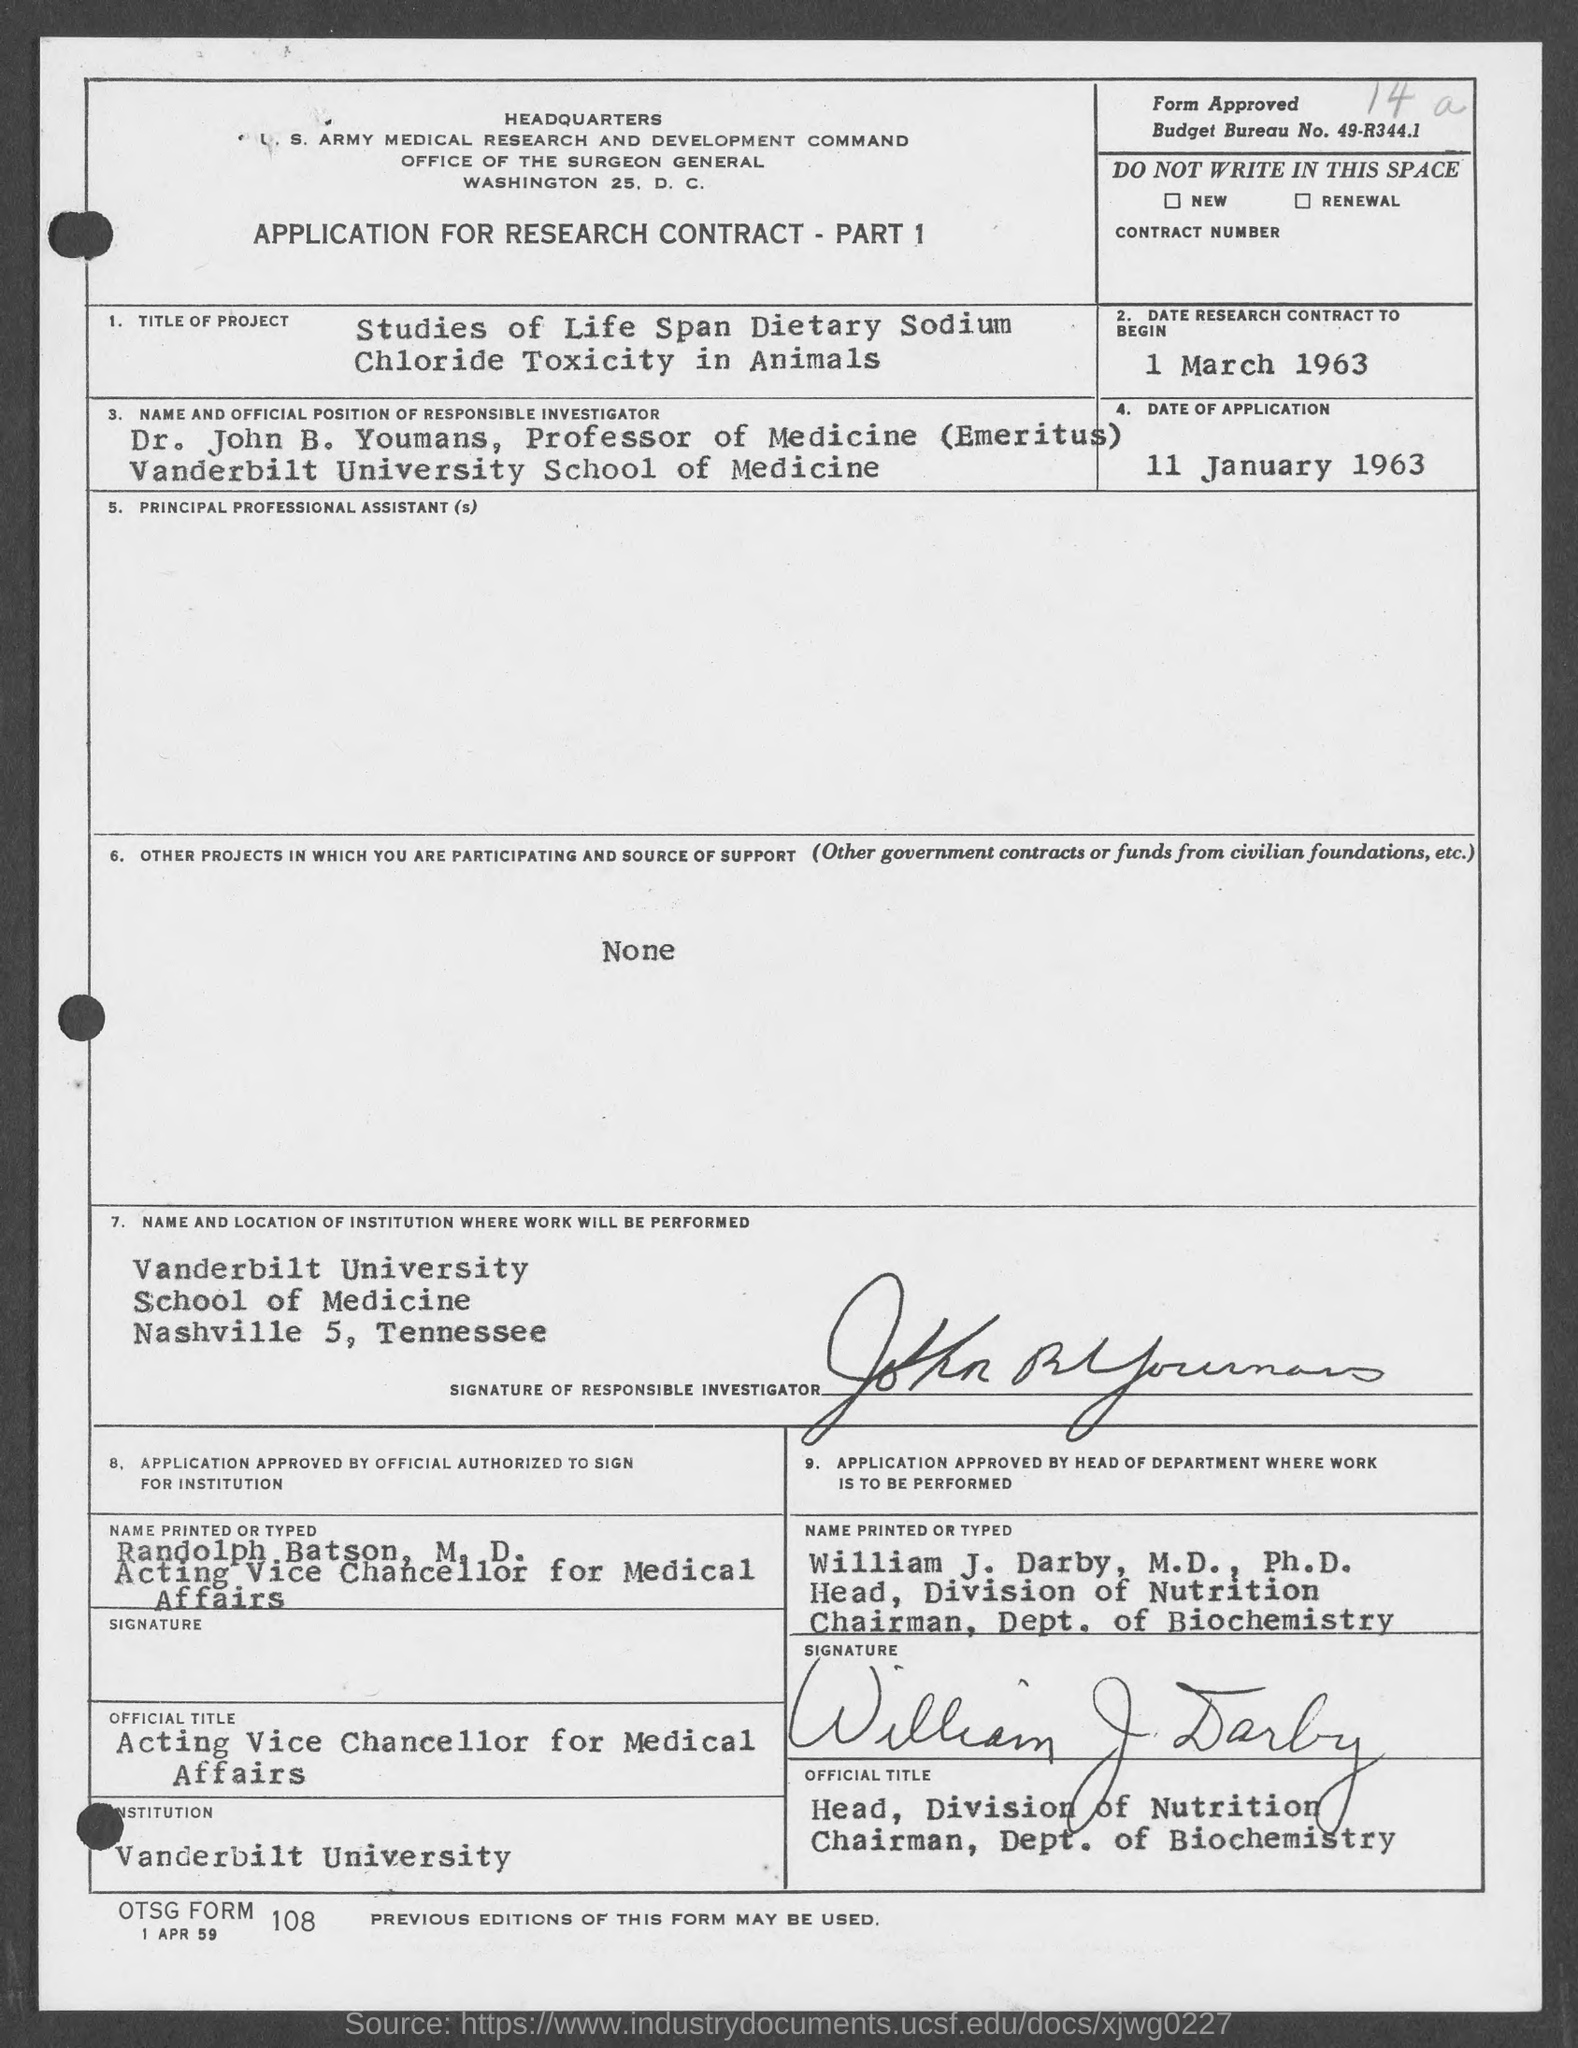What is the budget bureau no. mentioned in the given form ?
Your answer should be compact. 49-R344.1. What is the date of research contract to begin as mentioned in the give page ?
Your answer should be compact. 1 March 1963. What is the date of application mentioned in the given form ?
Offer a very short reply. 11 january 1963. What is the title of the project mentioned in the given form ?
Offer a terse response. Studies of life span dietary sodium chloride toxicity in animals. What is the name of the institution mentioned in the given page ?
Keep it short and to the point. Vanderbilt University. 